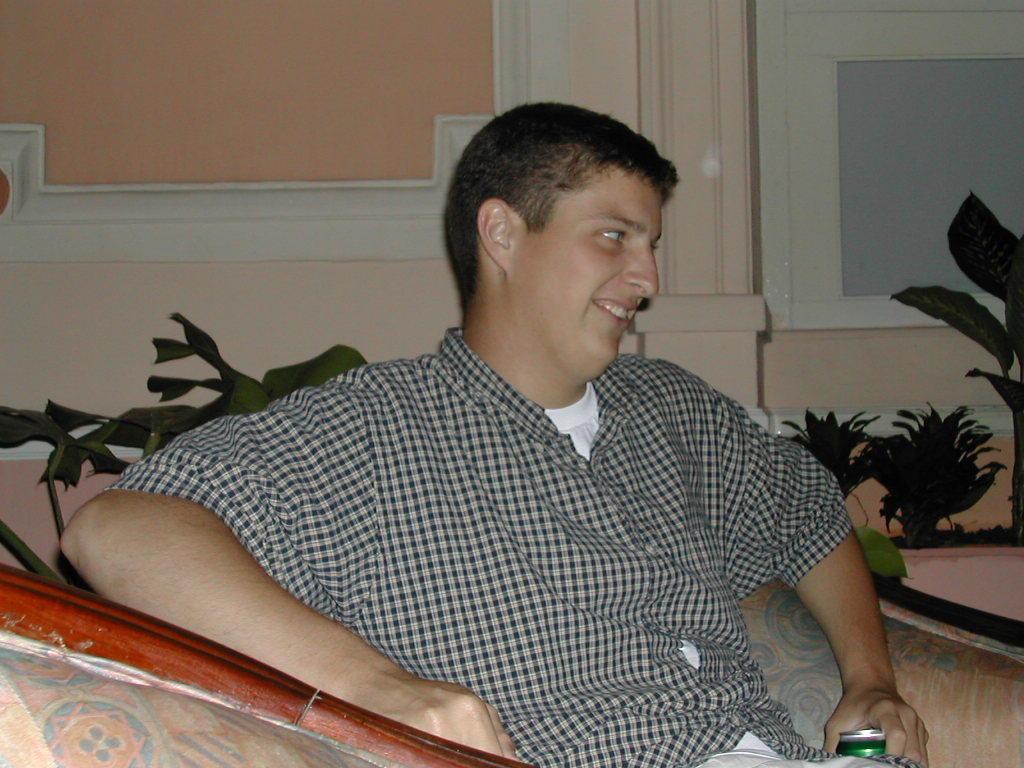Please provide a concise description of this image. The man in white shirt and black check shirt is sitting on the sofa. He is holding a green color coke bottle in his hand. He is smiling. Behind him, we see a flower pot and a wall in light pink color. On the right side of the picture, we see flower pots and a whiteboard. This picture is clicked inside the room. 